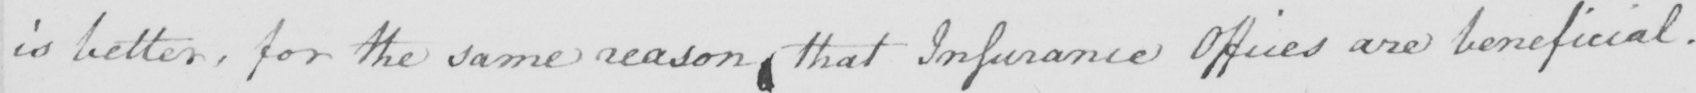Please provide the text content of this handwritten line. is better , for the same reason that Inssurance Offices are beneficial . 